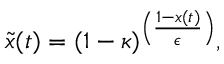Convert formula to latex. <formula><loc_0><loc_0><loc_500><loc_500>\tilde { x } ( t ) = ( 1 - \kappa ) ^ { \left ( \frac { 1 - x ( t ) } { \epsilon } \right ) } ,</formula> 